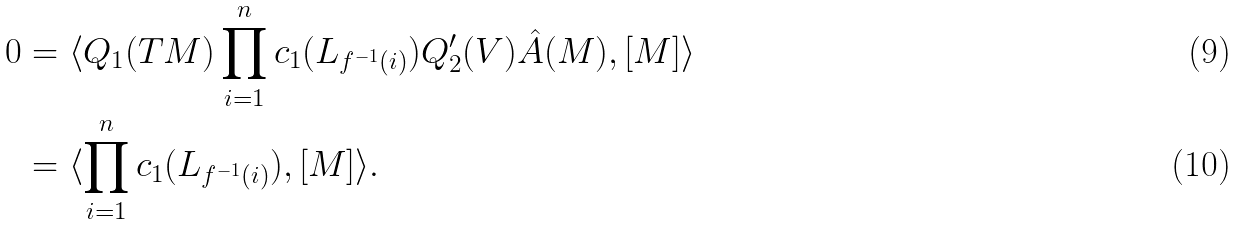Convert formula to latex. <formula><loc_0><loc_0><loc_500><loc_500>0 & = \langle Q _ { 1 } ( T M ) \prod _ { i = 1 } ^ { n } c _ { 1 } ( L _ { f ^ { - 1 } ( i ) } ) Q _ { 2 } ^ { \prime } ( V ) \hat { A } ( M ) , [ M ] \rangle \\ & = \langle \prod _ { i = 1 } ^ { n } c _ { 1 } ( L _ { f ^ { - 1 } ( i ) } ) , [ M ] \rangle .</formula> 